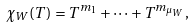<formula> <loc_0><loc_0><loc_500><loc_500>\chi _ { W } ( T ) = T ^ { m _ { 1 } } + \dots + T ^ { m _ { \mu _ { W } } } ,</formula> 